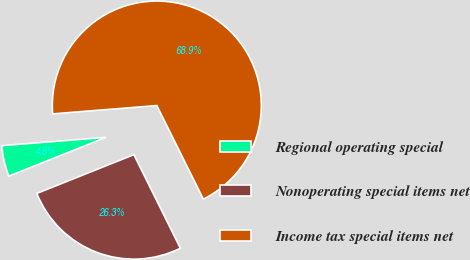Convert chart. <chart><loc_0><loc_0><loc_500><loc_500><pie_chart><fcel>Regional operating special<fcel>Nonoperating special items net<fcel>Income tax special items net<nl><fcel>4.78%<fcel>26.29%<fcel>68.92%<nl></chart> 